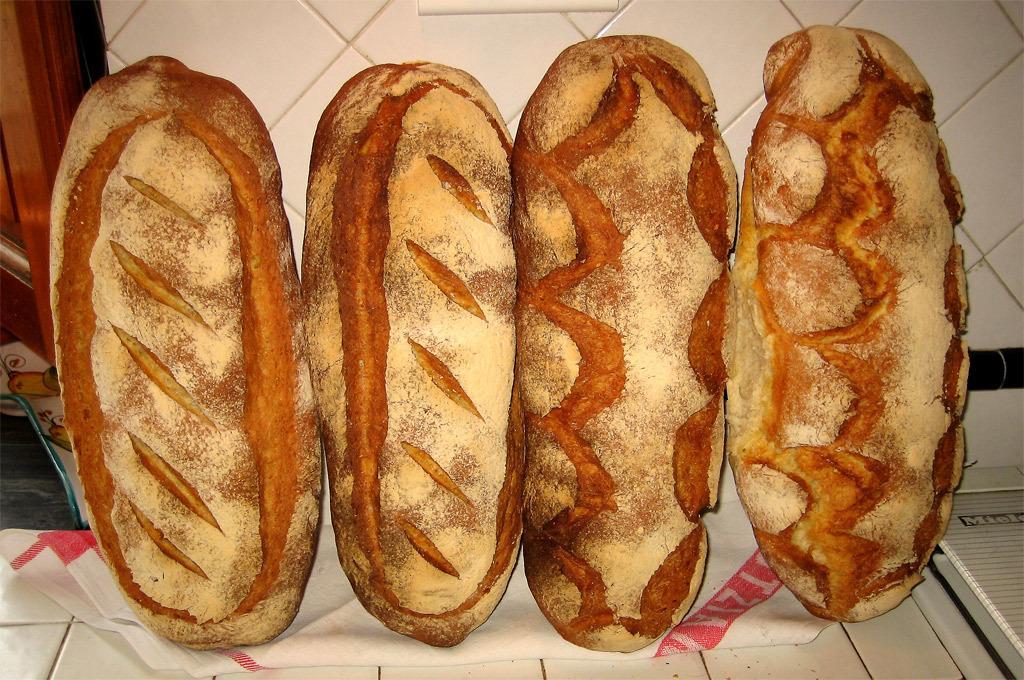Please provide a concise description of this image. In this image we can see four hot dogs placed vertically on a paper napkin. 